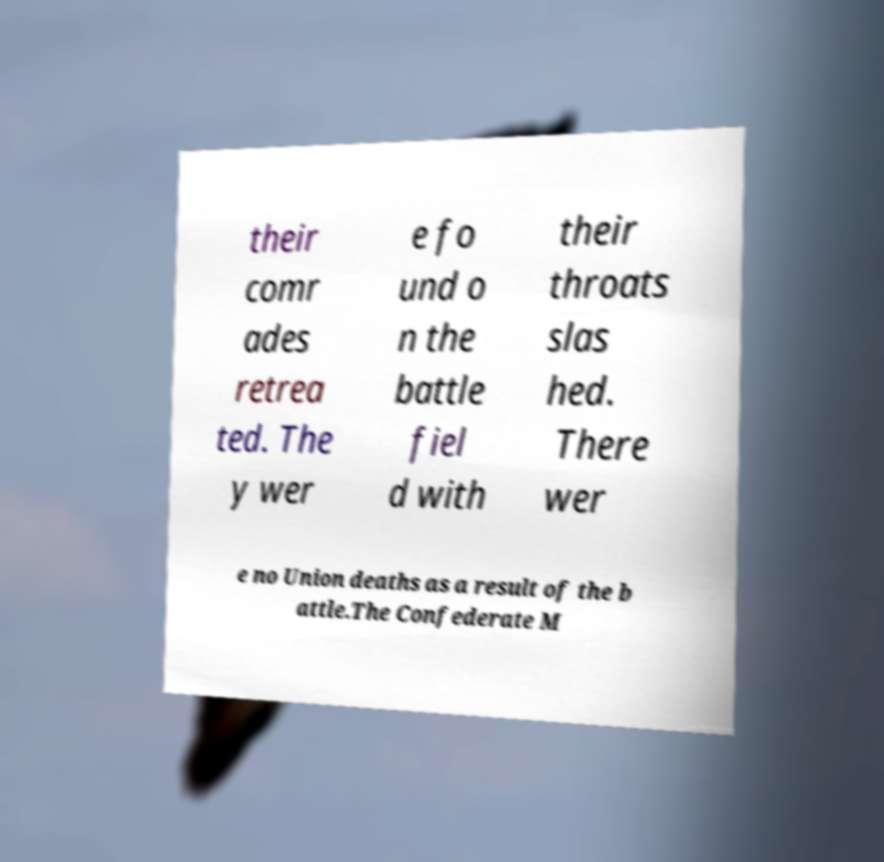What messages or text are displayed in this image? I need them in a readable, typed format. their comr ades retrea ted. The y wer e fo und o n the battle fiel d with their throats slas hed. There wer e no Union deaths as a result of the b attle.The Confederate M 